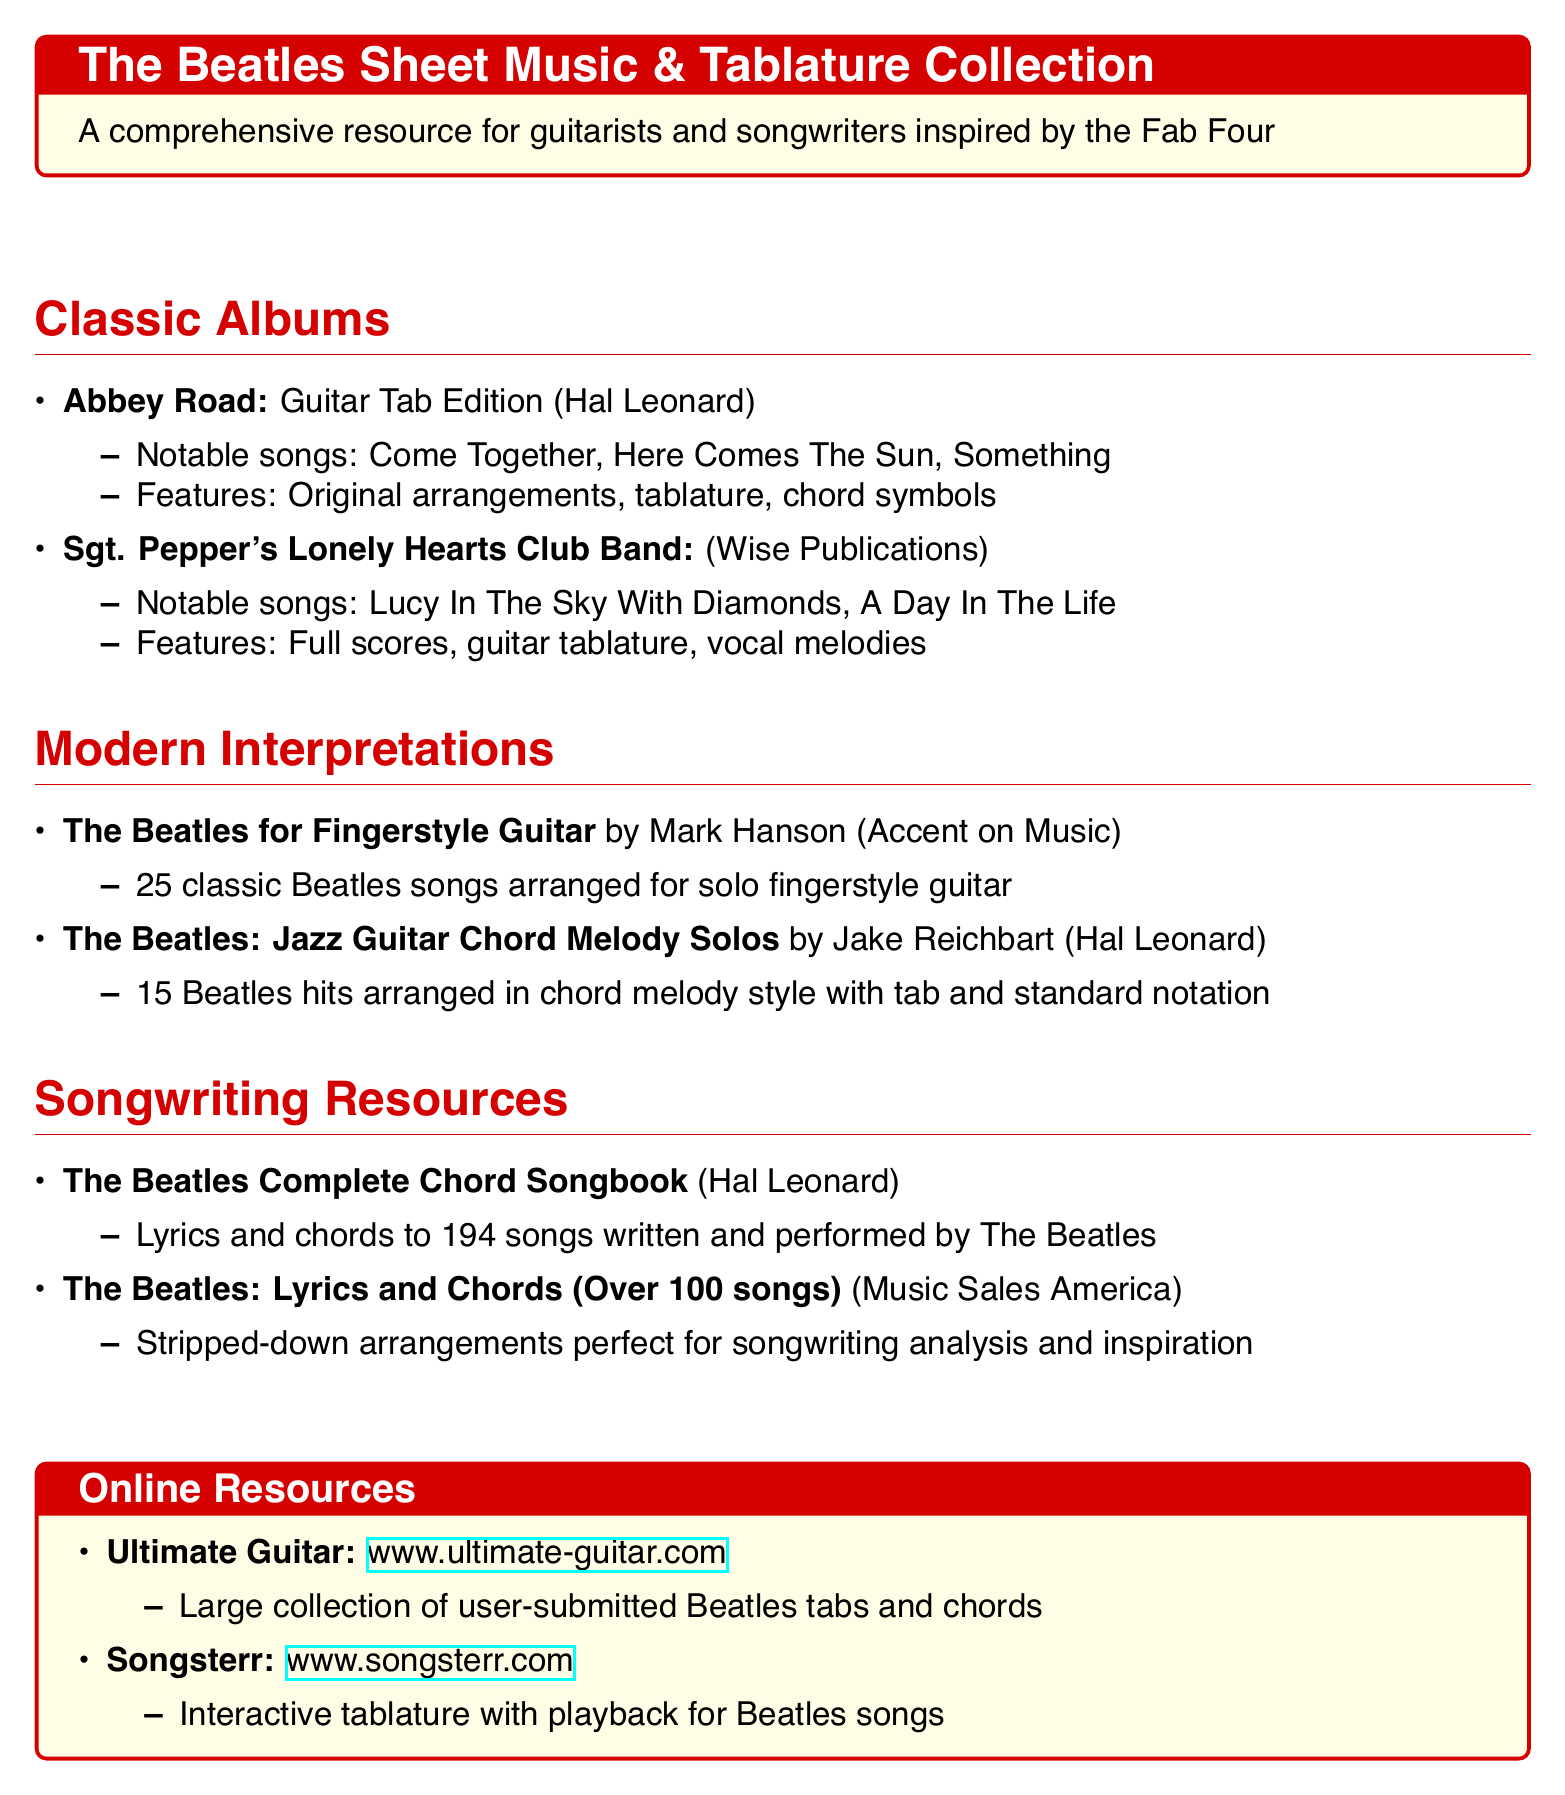What is the title of the first album listed? The first album listed in the "Classic Albums" section is "Abbey Road."
Answer: Abbey Road How many notable songs are mentioned for "Sgt. Pepper's Lonely Hearts Club Band"? There are two notable songs mentioned for "Sgt. Pepper's Lonely Hearts Club Band."
Answer: 2 Who is the author of "The Beatles for Fingerstyle Guitar"? The author of "The Beatles for Fingerstyle Guitar" is Mark Hanson.
Answer: Mark Hanson What type of arrangements does "The Beatles: Jazz Guitar Chord Melody Solos" provide? This book provides chord melody style arrangements.
Answer: Chord melody style Which resource features user-submitted Beatles tabs and chords? The resource that features user-submitted tabs and chords is Ultimate Guitar.
Answer: Ultimate Guitar How many songs does "The Beatles Complete Chord Songbook" cover? The Beatles Complete Chord Songbook covers 194 songs.
Answer: 194 songs What color is used for the document's title section? The title section of the document is colored beatlesred.
Answer: beatlesred What is the main focus of the catalogs organized by album? The catalogs focus on sheet music and tablature books.
Answer: Sheet music and tablature books 